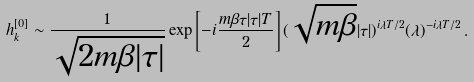Convert formula to latex. <formula><loc_0><loc_0><loc_500><loc_500>h _ { k } ^ { [ 0 ] } \sim \frac { 1 } { \sqrt { 2 m \beta | \tau | } } \exp \left [ - i \frac { m \beta \tau | \tau | T } { 2 } \right ] ( \sqrt { m \beta } | \tau | ) ^ { i \lambda T / 2 } ( \lambda ) ^ { - i \lambda T / 2 } \, .</formula> 